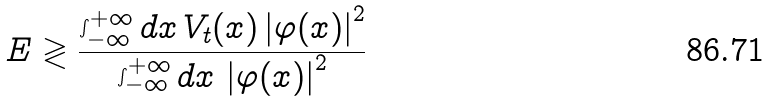Convert formula to latex. <formula><loc_0><loc_0><loc_500><loc_500>E \gtrless \frac { \int _ { - \infty } ^ { + \infty } d x \, V _ { t } ( x ) \left | \varphi ( x ) \right | ^ { 2 } } { \int _ { - \infty } ^ { + \infty } d x \, \left | \varphi ( x ) \right | ^ { 2 } }</formula> 